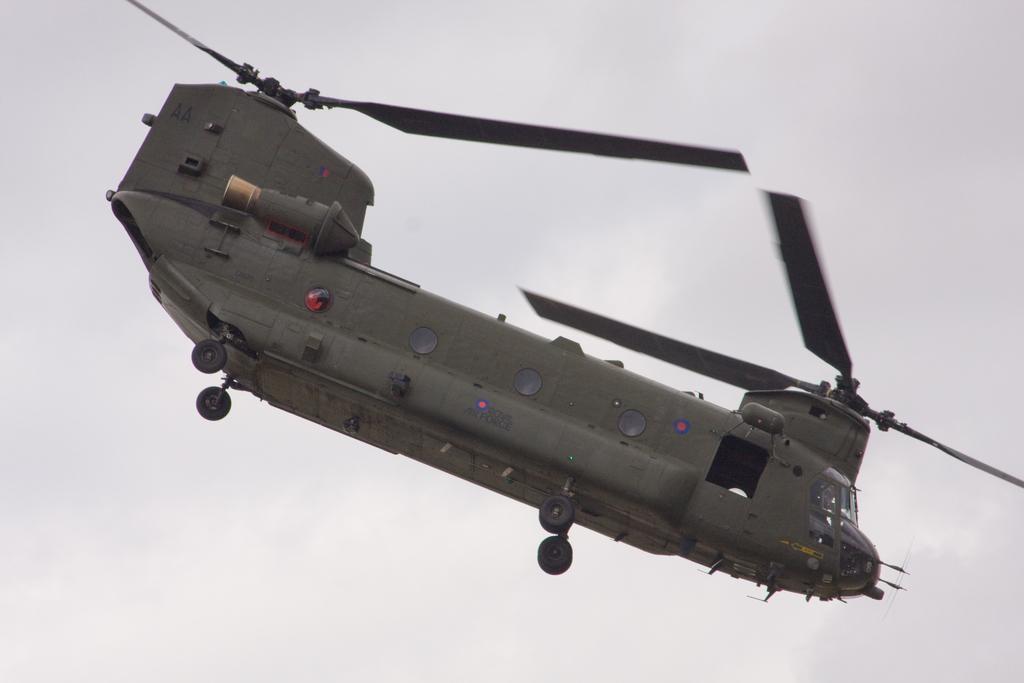Could you give a brief overview of what you see in this image? In this picture we can see an airplane flying in the air and there is a white background. 